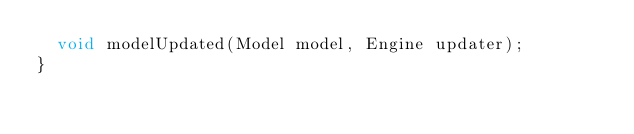<code> <loc_0><loc_0><loc_500><loc_500><_Java_>	void modelUpdated(Model model, Engine updater);
}
</code> 